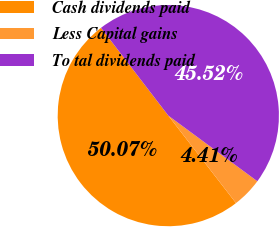<chart> <loc_0><loc_0><loc_500><loc_500><pie_chart><fcel>Cash dividends paid<fcel>Less Capital gains<fcel>To tal dividends paid<nl><fcel>50.07%<fcel>4.41%<fcel>45.52%<nl></chart> 